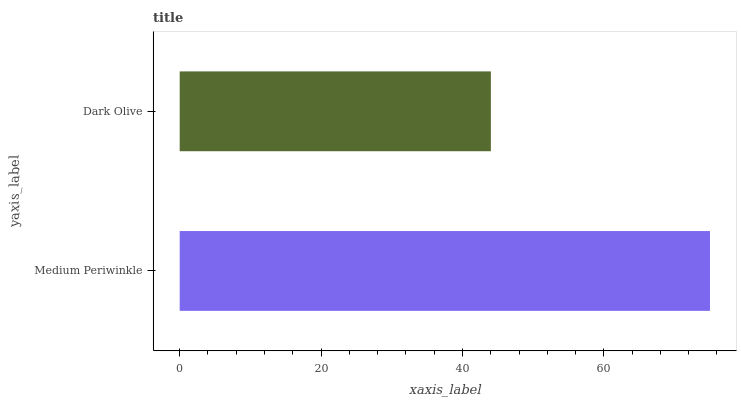Is Dark Olive the minimum?
Answer yes or no. Yes. Is Medium Periwinkle the maximum?
Answer yes or no. Yes. Is Dark Olive the maximum?
Answer yes or no. No. Is Medium Periwinkle greater than Dark Olive?
Answer yes or no. Yes. Is Dark Olive less than Medium Periwinkle?
Answer yes or no. Yes. Is Dark Olive greater than Medium Periwinkle?
Answer yes or no. No. Is Medium Periwinkle less than Dark Olive?
Answer yes or no. No. Is Medium Periwinkle the high median?
Answer yes or no. Yes. Is Dark Olive the low median?
Answer yes or no. Yes. Is Dark Olive the high median?
Answer yes or no. No. Is Medium Periwinkle the low median?
Answer yes or no. No. 